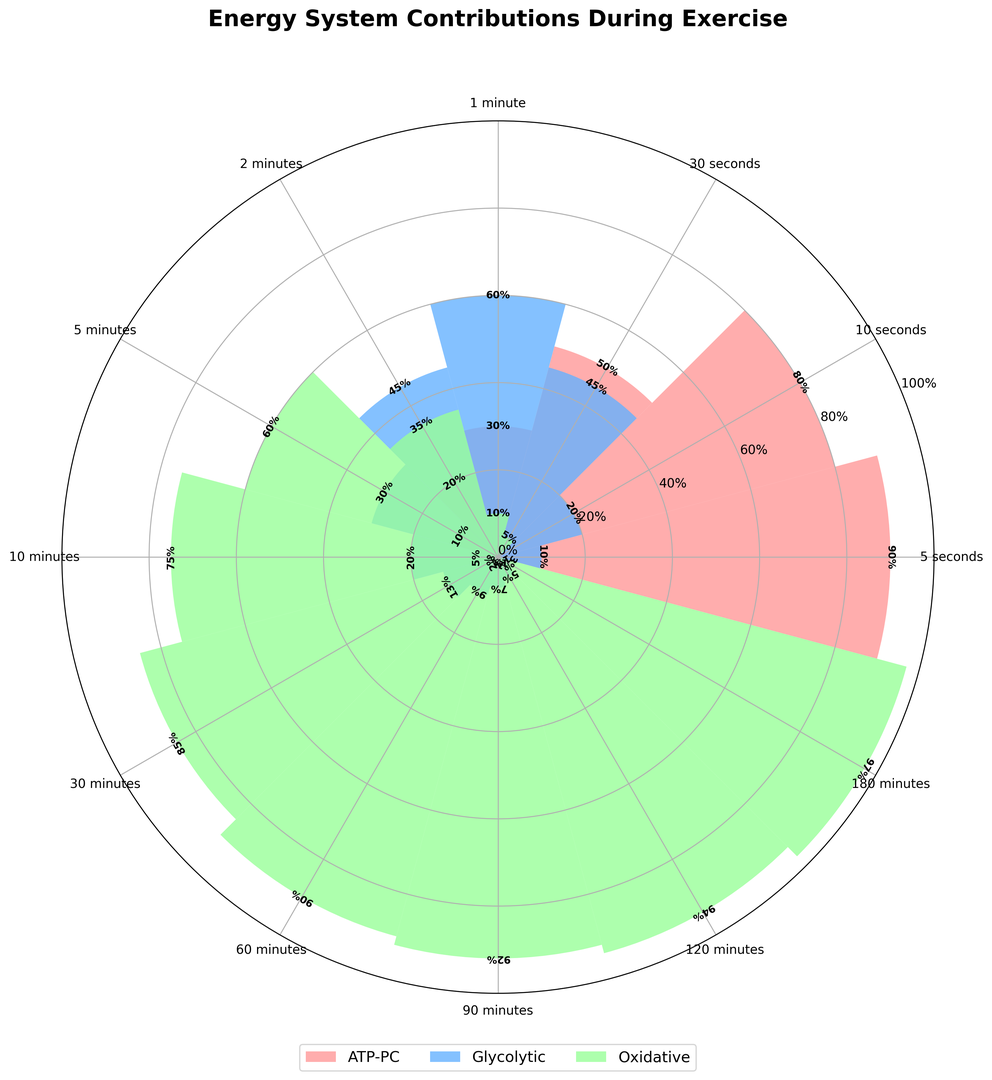What's the predominant energy system during a 5-second exercise? The chart shows the distribution of energy systems for various exercise durations. For the 5-second duration, the red segment (representing ATP-PC) is the largest compared to the other segments.
Answer: ATP-PC How does the contribution of the Glycolytic system change from 1 minute to 10 minutes? For 1 minute, the chart shows a 60% contribution from the Glycolytic system. For 10 minutes, it decreases to a 20% contribution. The difference is 60% - 20%.
Answer: Decreases by 40% Which energy system takes over after the ATP-PC system significantly drops after 10 seconds? Observing the figure, after the ATP-PC system drops, the Glycolytic system (blue section) fills the majority of the contribution.
Answer: Glycolytic How does the oxidative system contribution compare between 5 minutes and 60 minutes? At 5 minutes, the oxidative system's contribution is 60%, and at 60 minutes, it increases to 90%. To find the difference, 90% - 60%.
Answer: Increases by 30% What is the energy system with the smallest contribution for a 2-minute duration? For the 2-minute duration, the chart shows that the ATP-PC system (red section) has the smallest contribution among the three systems.
Answer: ATP-PC For which duration does the ATP-PC system contribute the least and what is this contribution? Looking at the polar chart, the ATP-PC system is almost non-existent beyond certain durations, reaching 0% beyond 120 minutes.
Answer: 0% at 180 minutes By how much does the oxidative system's contribution increase from 10 minutes to 30 minutes? At 10 minutes, the oxidative contribution is 75%, and at 30 minutes, it is 85%. Therefore, the increase is 85% - 75%.
Answer: Increases by 10% What is the oxidative system's contribution when the Glycolytic system peaks? The Glycolytic system peaks at the 1-minute mark with 60%. During this same duration, the oxidative system has a 10% contribution.
Answer: 10% How does the total contribution from Glycolytic and Oxidative systems change from 1 minute to 5 minutes? At 1 minute, the combined total is 60% (Glycolytic) + 10% (Oxidative) = 70%. At 5 minutes, the combined total is 30% (Glycolytic) + 60% (Oxidative) = 90%. The increase is 90% - 70%.
Answer: Increases by 20% 